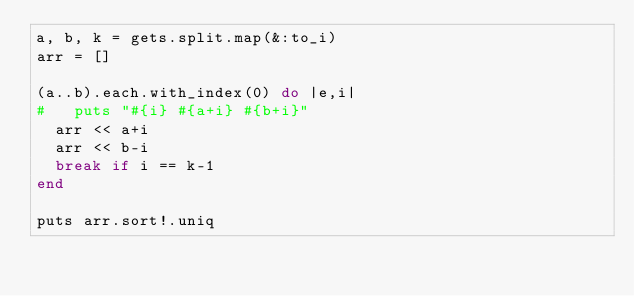<code> <loc_0><loc_0><loc_500><loc_500><_Ruby_>a, b, k = gets.split.map(&:to_i)
arr = []

(a..b).each.with_index(0) do |e,i|
#   puts "#{i} #{a+i} #{b+i}"
  arr << a+i
  arr << b-i
  break if i == k-1
end

puts arr.sort!.uniq
</code> 